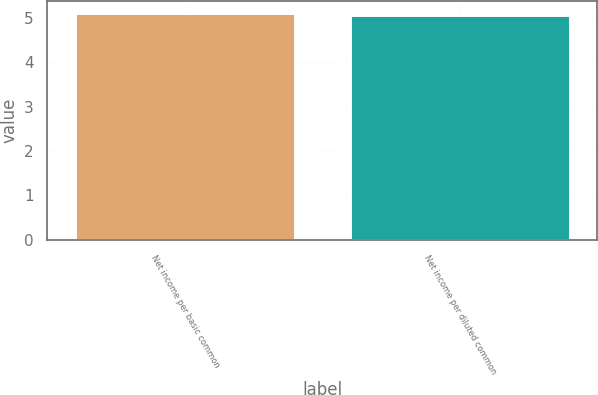Convert chart to OTSL. <chart><loc_0><loc_0><loc_500><loc_500><bar_chart><fcel>Net income per basic common<fcel>Net income per diluted common<nl><fcel>5.12<fcel>5.07<nl></chart> 